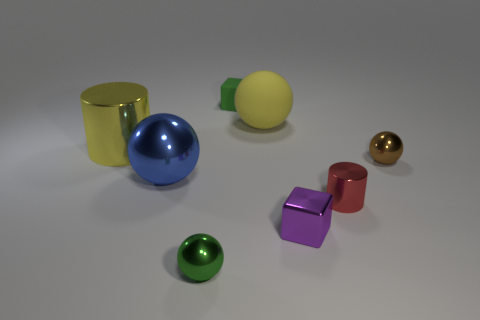Does the small ball to the right of the green metallic object have the same color as the big rubber thing?
Your answer should be compact. No. The thing that is right of the purple cube and behind the big blue sphere is made of what material?
Give a very brief answer. Metal. Is there another object that has the same size as the green rubber thing?
Offer a terse response. Yes. What number of cyan metallic objects are there?
Your response must be concise. 0. There is a matte cube; what number of shiny spheres are on the left side of it?
Your answer should be very brief. 2. Does the yellow cylinder have the same material as the blue ball?
Make the answer very short. Yes. What number of things are on the left side of the big rubber sphere and in front of the tiny rubber thing?
Offer a terse response. 3. How many other things are the same color as the tiny metallic cylinder?
Your response must be concise. 0. What number of blue things are either rubber objects or cylinders?
Offer a very short reply. 0. How big is the blue object?
Ensure brevity in your answer.  Large. 